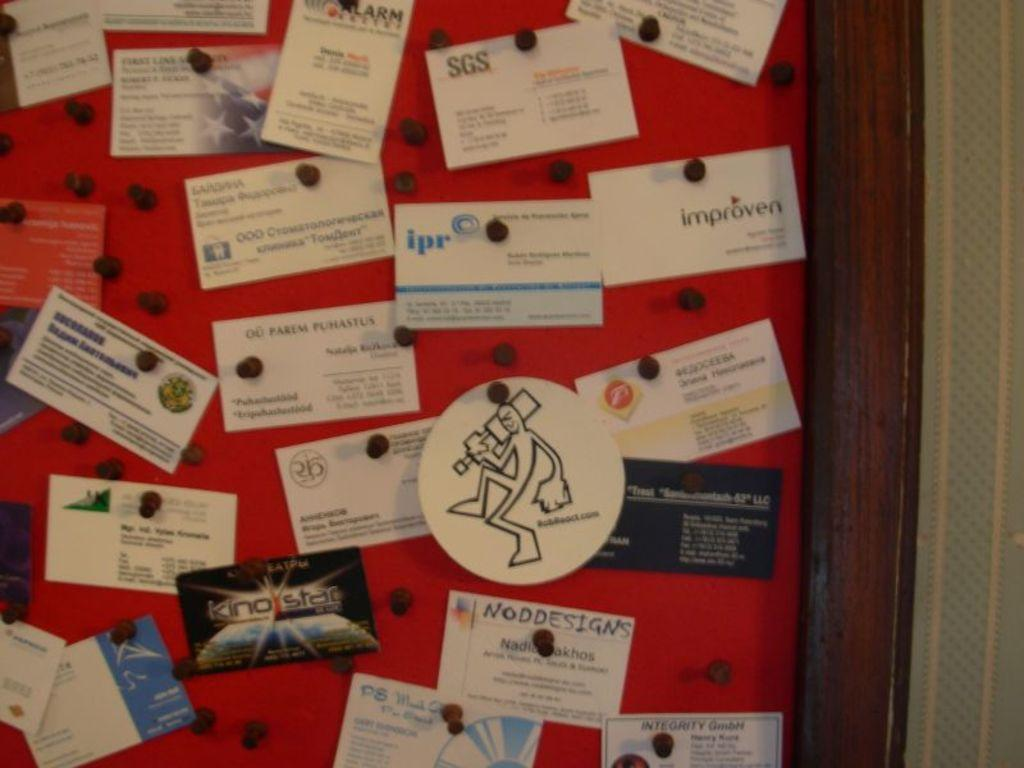<image>
Write a terse but informative summary of the picture. Many business cards are pinned to a board including one in blue and white that has ipr on it. 